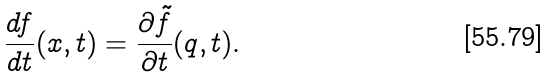<formula> <loc_0><loc_0><loc_500><loc_500>\frac { d f } { d t } ( x , t ) = \frac { \partial \tilde { f } } { \partial t } ( q , t ) .</formula> 